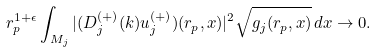Convert formula to latex. <formula><loc_0><loc_0><loc_500><loc_500>r _ { p } ^ { 1 + \epsilon } \int _ { M _ { j } } | ( D _ { j } ^ { ( + ) } ( k ) u _ { j } ^ { ( + ) } ) ( r _ { p } , x ) | ^ { 2 } \sqrt { g _ { j } ( r _ { p } , x ) } \, d x \to 0 .</formula> 